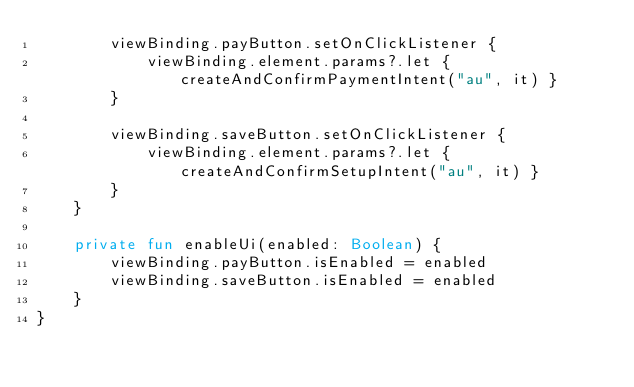Convert code to text. <code><loc_0><loc_0><loc_500><loc_500><_Kotlin_>        viewBinding.payButton.setOnClickListener {
            viewBinding.element.params?.let { createAndConfirmPaymentIntent("au", it) }
        }

        viewBinding.saveButton.setOnClickListener {
            viewBinding.element.params?.let { createAndConfirmSetupIntent("au", it) }
        }
    }

    private fun enableUi(enabled: Boolean) {
        viewBinding.payButton.isEnabled = enabled
        viewBinding.saveButton.isEnabled = enabled
    }
}
</code> 